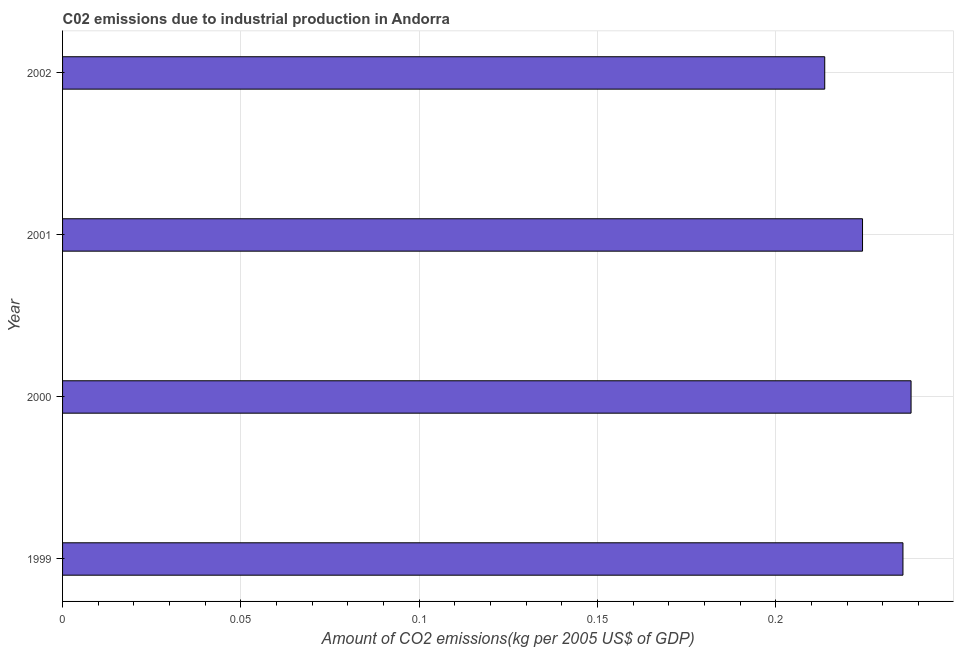What is the title of the graph?
Ensure brevity in your answer.  C02 emissions due to industrial production in Andorra. What is the label or title of the X-axis?
Offer a very short reply. Amount of CO2 emissions(kg per 2005 US$ of GDP). What is the amount of co2 emissions in 2002?
Ensure brevity in your answer.  0.21. Across all years, what is the maximum amount of co2 emissions?
Make the answer very short. 0.24. Across all years, what is the minimum amount of co2 emissions?
Your answer should be very brief. 0.21. In which year was the amount of co2 emissions maximum?
Offer a terse response. 2000. In which year was the amount of co2 emissions minimum?
Your response must be concise. 2002. What is the sum of the amount of co2 emissions?
Offer a very short reply. 0.91. What is the difference between the amount of co2 emissions in 2000 and 2001?
Provide a succinct answer. 0.01. What is the average amount of co2 emissions per year?
Offer a very short reply. 0.23. What is the median amount of co2 emissions?
Ensure brevity in your answer.  0.23. What is the ratio of the amount of co2 emissions in 2000 to that in 2001?
Provide a short and direct response. 1.06. What is the difference between the highest and the second highest amount of co2 emissions?
Make the answer very short. 0. What is the difference between the highest and the lowest amount of co2 emissions?
Offer a terse response. 0.02. Are all the bars in the graph horizontal?
Offer a terse response. Yes. How many years are there in the graph?
Give a very brief answer. 4. What is the difference between two consecutive major ticks on the X-axis?
Your response must be concise. 0.05. What is the Amount of CO2 emissions(kg per 2005 US$ of GDP) in 1999?
Make the answer very short. 0.24. What is the Amount of CO2 emissions(kg per 2005 US$ of GDP) in 2000?
Offer a terse response. 0.24. What is the Amount of CO2 emissions(kg per 2005 US$ of GDP) in 2001?
Your answer should be very brief. 0.22. What is the Amount of CO2 emissions(kg per 2005 US$ of GDP) in 2002?
Provide a short and direct response. 0.21. What is the difference between the Amount of CO2 emissions(kg per 2005 US$ of GDP) in 1999 and 2000?
Give a very brief answer. -0. What is the difference between the Amount of CO2 emissions(kg per 2005 US$ of GDP) in 1999 and 2001?
Keep it short and to the point. 0.01. What is the difference between the Amount of CO2 emissions(kg per 2005 US$ of GDP) in 1999 and 2002?
Ensure brevity in your answer.  0.02. What is the difference between the Amount of CO2 emissions(kg per 2005 US$ of GDP) in 2000 and 2001?
Your answer should be very brief. 0.01. What is the difference between the Amount of CO2 emissions(kg per 2005 US$ of GDP) in 2000 and 2002?
Give a very brief answer. 0.02. What is the difference between the Amount of CO2 emissions(kg per 2005 US$ of GDP) in 2001 and 2002?
Give a very brief answer. 0.01. What is the ratio of the Amount of CO2 emissions(kg per 2005 US$ of GDP) in 1999 to that in 2000?
Give a very brief answer. 0.99. What is the ratio of the Amount of CO2 emissions(kg per 2005 US$ of GDP) in 1999 to that in 2001?
Provide a succinct answer. 1.05. What is the ratio of the Amount of CO2 emissions(kg per 2005 US$ of GDP) in 1999 to that in 2002?
Your response must be concise. 1.1. What is the ratio of the Amount of CO2 emissions(kg per 2005 US$ of GDP) in 2000 to that in 2001?
Your response must be concise. 1.06. What is the ratio of the Amount of CO2 emissions(kg per 2005 US$ of GDP) in 2000 to that in 2002?
Give a very brief answer. 1.11. What is the ratio of the Amount of CO2 emissions(kg per 2005 US$ of GDP) in 2001 to that in 2002?
Your response must be concise. 1.05. 